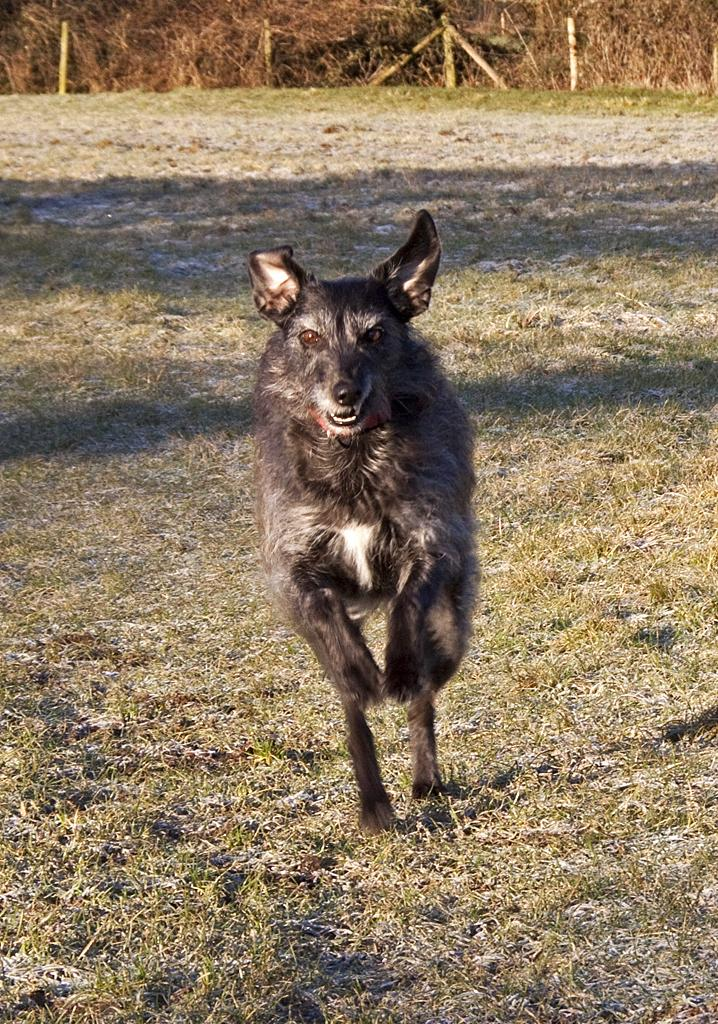What type of animal is present in the image? There is an animal in the image, but its specific type cannot be determined from the provided facts. What type of vegetation is visible in the image? There is grass in the image. What can be seen in the background of the image? There are trees and fencing in the background of the image. What type of beef is being served on a plate in the image? There is no beef or plate present in the image. Can you tell me how many blades of grass are visible in the image? It is not possible to determine the exact number of blades of grass visible in the image. 